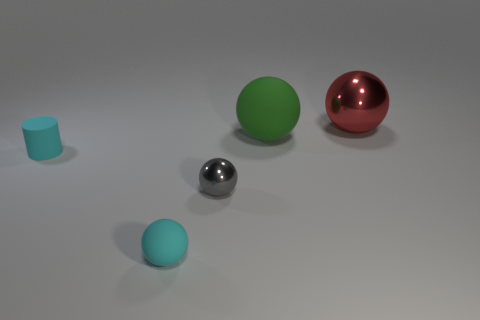Add 3 large shiny objects. How many objects exist? 8 Subtract all cylinders. How many objects are left? 4 Subtract all big red objects. Subtract all tiny cyan spheres. How many objects are left? 3 Add 3 matte spheres. How many matte spheres are left? 5 Add 5 small cyan matte cylinders. How many small cyan matte cylinders exist? 6 Subtract 0 yellow balls. How many objects are left? 5 